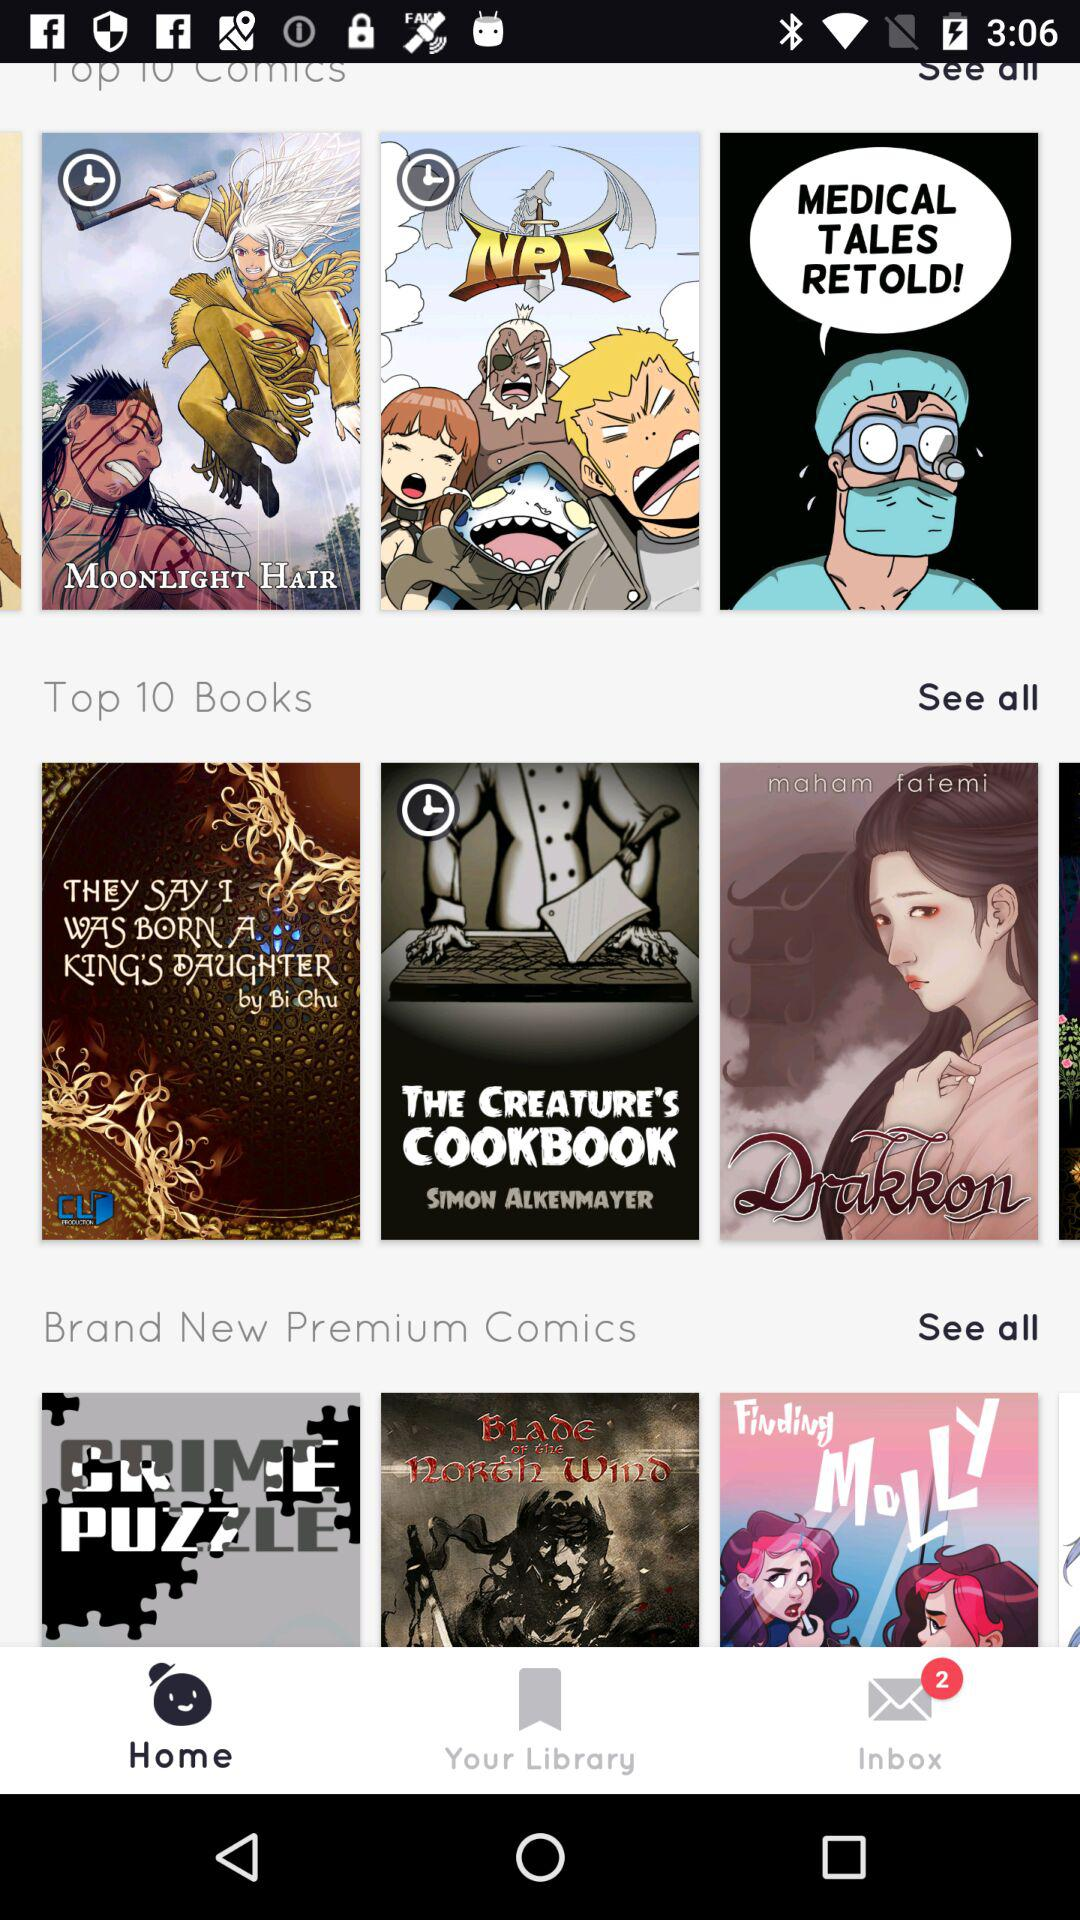Which are the brand-new premium comics? The brand-new premium comics are "CRIME PUZZLE", "Blade OF the North Wind" and "Finding MoLLY". 